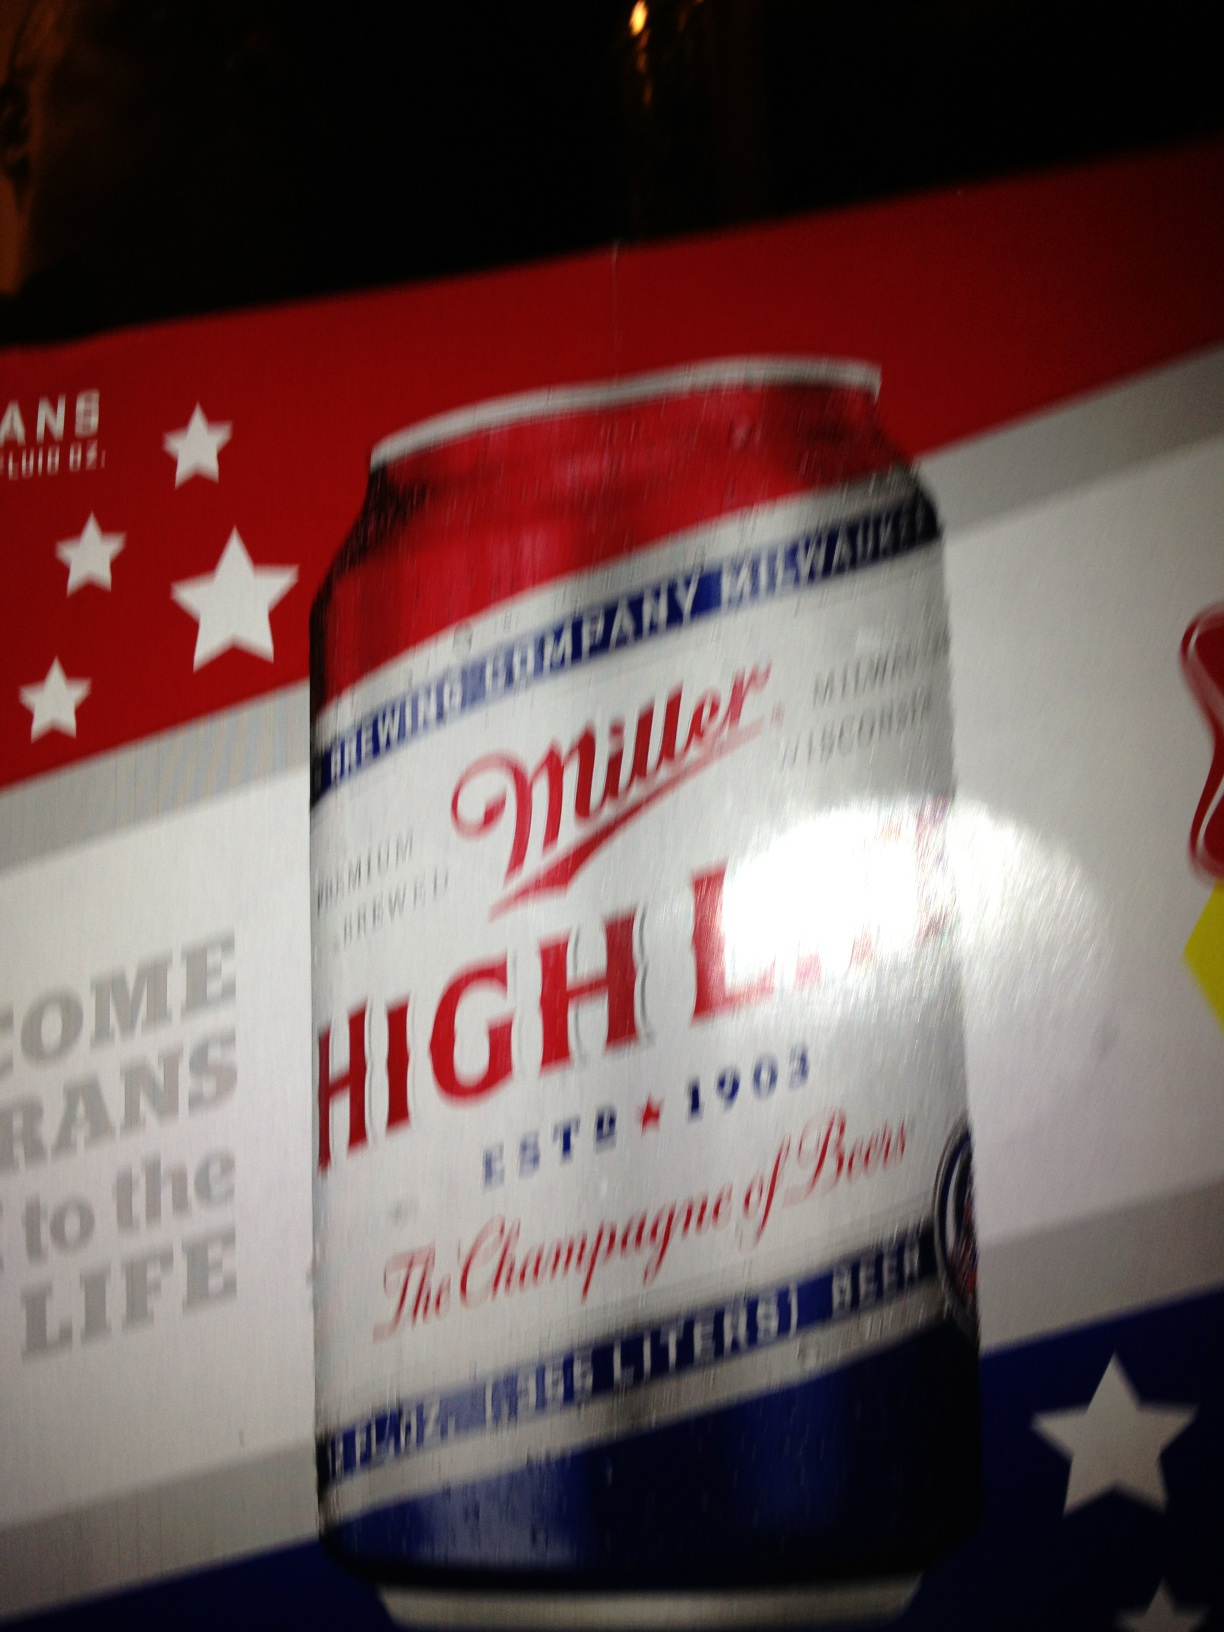What is this? from Vizwiz miller highlife beer 